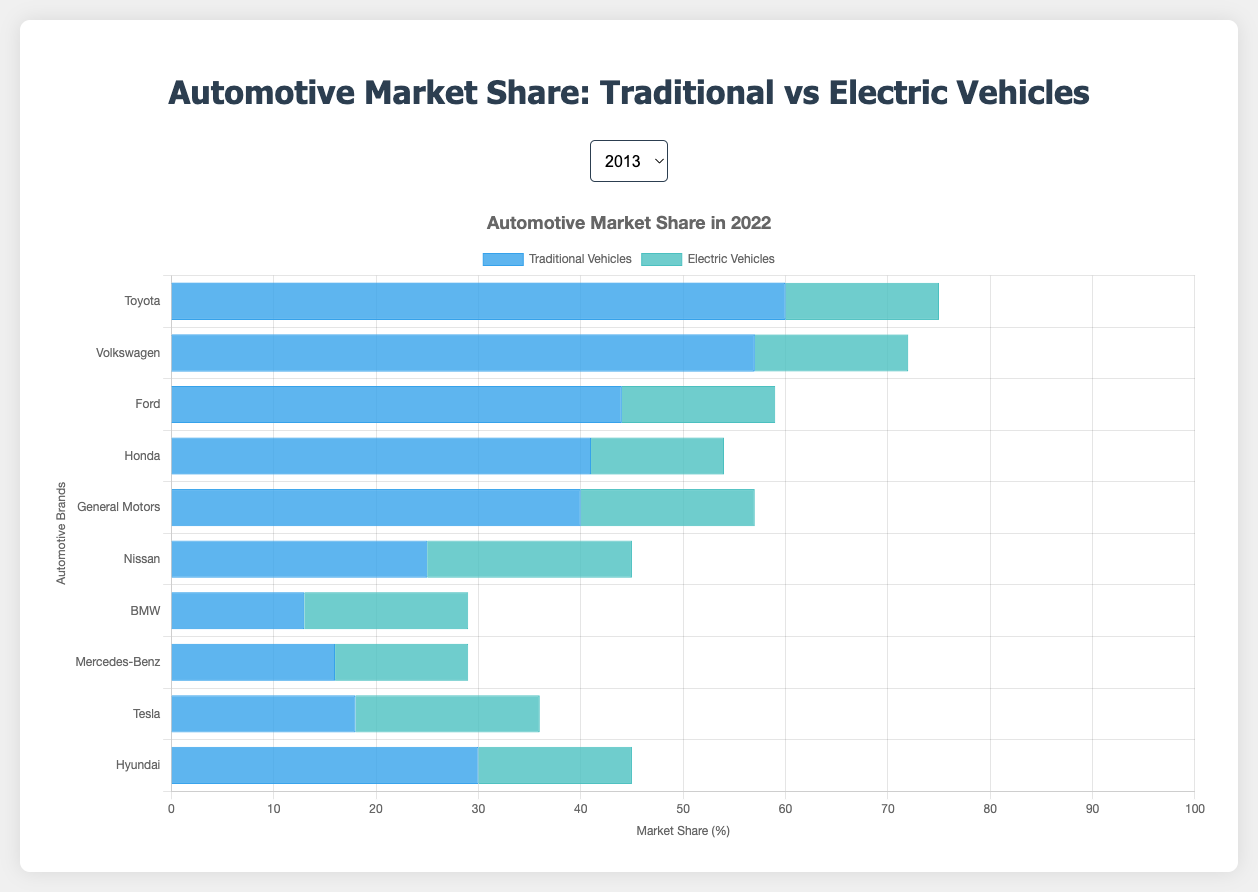Which brand had the highest market share for electric vehicles in 2022? By looking at the electric vehicle segment in the 2022 data, Tesla and Toyota both have the highest market share with 18 units each.
Answer: Tesla and Toyota How did Toyota's traditional vehicle market share change from 2013 to 2022? Toyota's traditional vehicle market share decreased from 80 in 2013 to 60 in 2022, which is a decline of 20 units.
Answer: Decreased by 20 units Which brand showed the most significant shift from traditional to electric vehicles between 2013 and 2022? To determine this, look at the difference in market share percentages between 2013 and 2022 for both traditional and electric vehicles. Tesla shows the most significant shift, going from 3 (traditional) in 2013 to 18 (electric) in 2022.
Answer: Tesla Comparing the year 2021, which brand has the greatest combined market share (traditional + electric) and what is the total? In 2021, add the traditional and electric market shares for each brand. The brand with the highest combined share is Toyota: 62 (traditional) + 13 (electric) = 75.
Answer: Toyota, 75 In 2019, how many more units did Toyota have in traditional vehicles compared to electric vehicles? Subtract the electric vehicle units from the traditional vehicle units for Toyota in 2019: 68 (traditional) - 7 (electric) = 61.
Answer: 61 What is the average traditional vehicle market share for General Motors across the decade? Sum the traditional vehicle market shares for General Motors from 2013 to 2022 and divide by the number of years (10): (60 + 59 + 57 + 55 + 53 + 51 + 49 + 46 + 43 + 40) / 10 = 51.3.
Answer: 51.3 Which brand had the smallest difference in market share between traditional and electric vehicles in 2020? Calculate the absolute differences for each brand in 2020: Toyota: 55, Volkswagen: 53, Ford: 40, Honda: 40, General Motors: 35, Nissan: 17, BMW: 7, Mercedes-Benz: 12, Tesla: 0, Hyundai: 25. Tesla had the smallest difference with 0.
Answer: Tesla By comparing electric vehicle market shares, which brand made the largest gain from 2021 to 2022? Calculate the difference in electric vehicle market shares from 2021 to 2022 for each brand. Hyundai has the largest gain: 15 (2022) - 12 (2021) = 3.
Answer: Hyundai In 2018, what was the total market share for Nissan considering both traditional and electric vehicles? Add the traditional and electric market shares for Nissan in 2018: 36 (traditional) + 9 (electric) = 45.
Answer: 45 